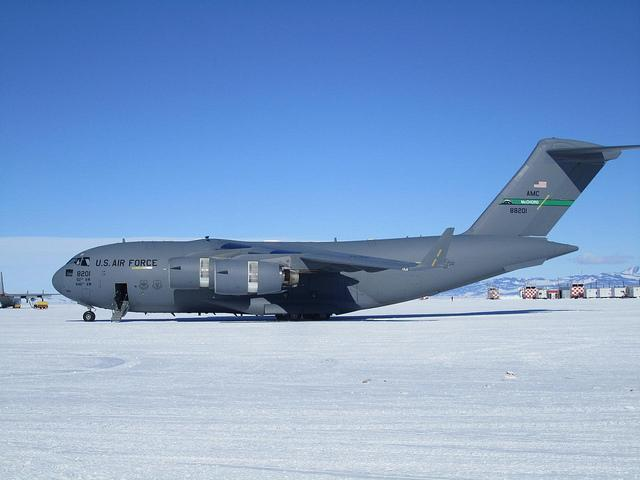The plane is most likely dropping off what to the people? Please explain your reasoning. supplies. The plane is dropping off supplies. 